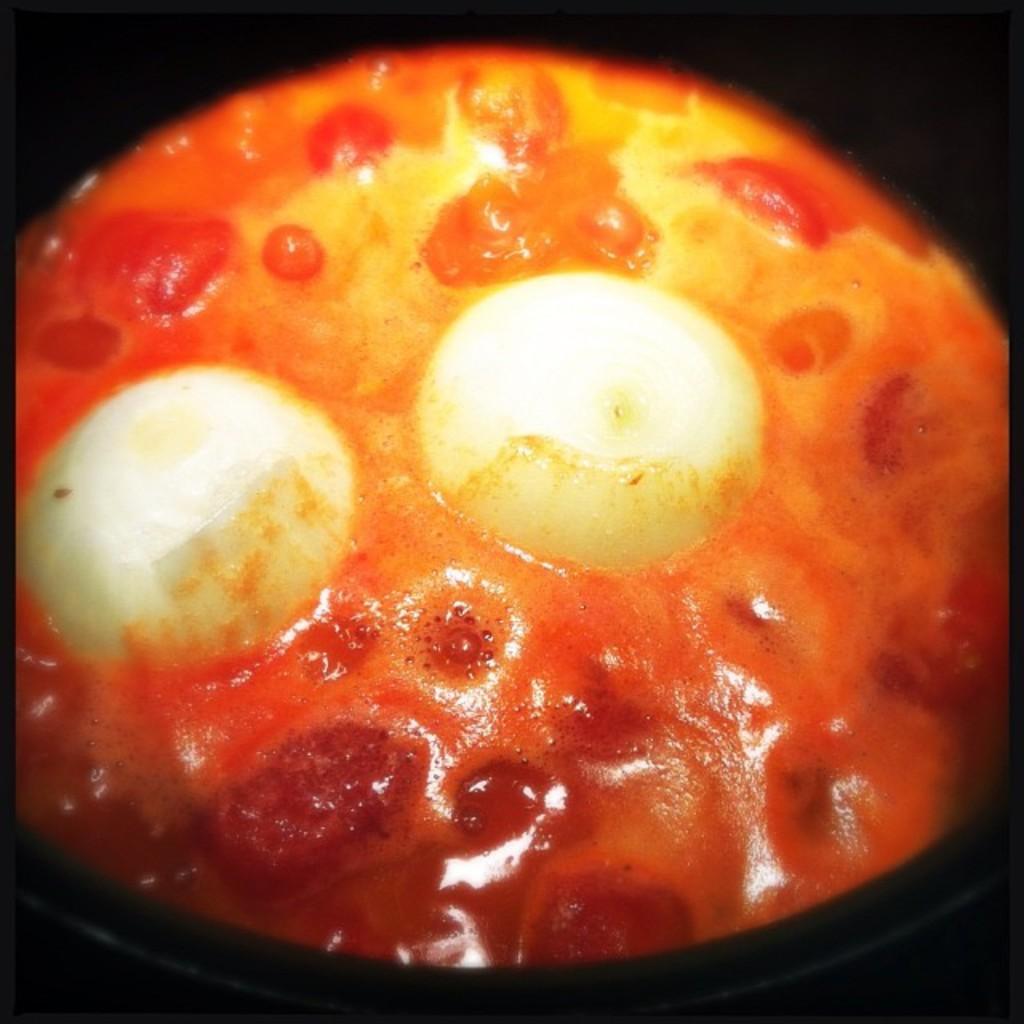Please provide a concise description of this image. In the picture I can see something in white, red and yellow in color. The background of the image is dark. 